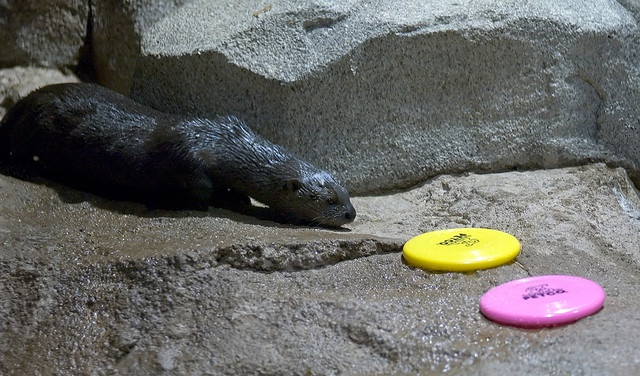Describe the objects in this image and their specific colors. I can see frisbee in black, violet, purple, and pink tones and frisbee in black, yellow, olive, khaki, and gold tones in this image. 